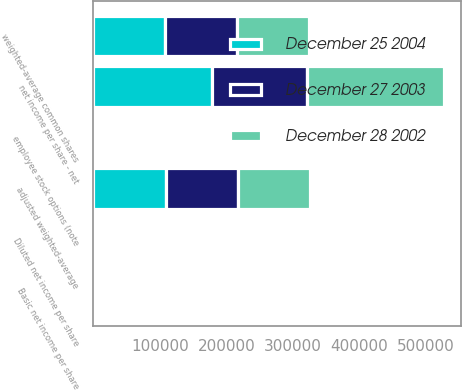<chart> <loc_0><loc_0><loc_500><loc_500><stacked_bar_chart><ecel><fcel>net income per share - net<fcel>weighted-average common shares<fcel>employee stock options (note<fcel>adjusted weighted-average<fcel>Basic net income per share<fcel>Diluted net income per share<nl><fcel>December 28 2002<fcel>205700<fcel>108161<fcel>869<fcel>109030<fcel>1.9<fcel>1.89<nl><fcel>December 25 2004<fcel>178634<fcel>108011<fcel>891<fcel>108902<fcel>1.65<fcel>1.64<nl><fcel>December 27 2003<fcel>142797<fcel>107774<fcel>427<fcel>108201<fcel>1.32<fcel>1.32<nl></chart> 